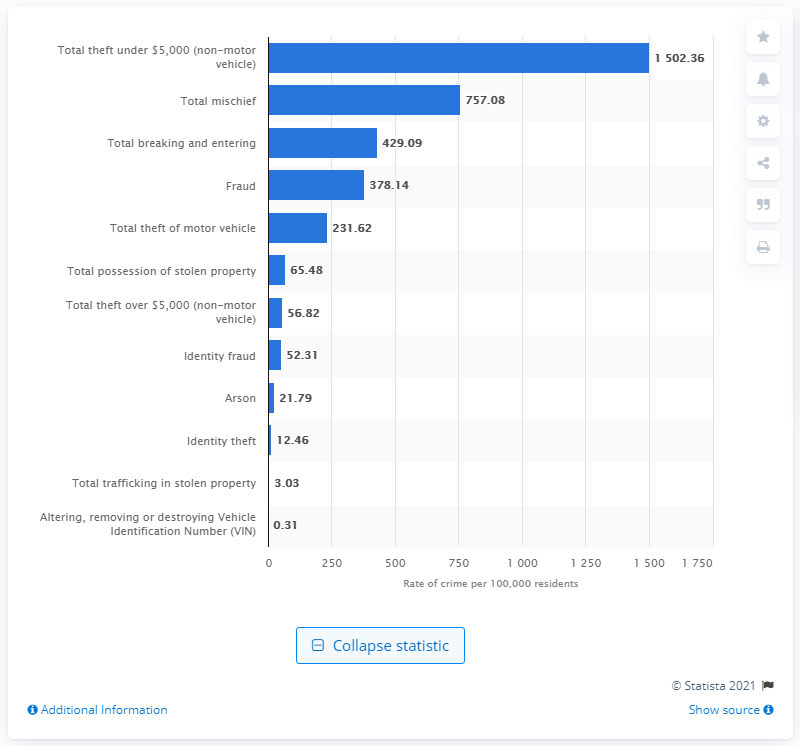What does the visual representation suggest about the trends of 'Total possession of stolen property' and 'Identity fraud' in Canada in 2019? The bar graph indicates that 'Total possession of stolen property' had a reported incident rate of 65.48 per 100,000 residents, whereas 'Identity fraud' had a slightly lower rate at 52.31 per 100,000 residents in Canada for the year 2019. This suggests that both types of crime were relatively less frequent compared to other categories such as theft or mischief, yet they still represented notable issues. 